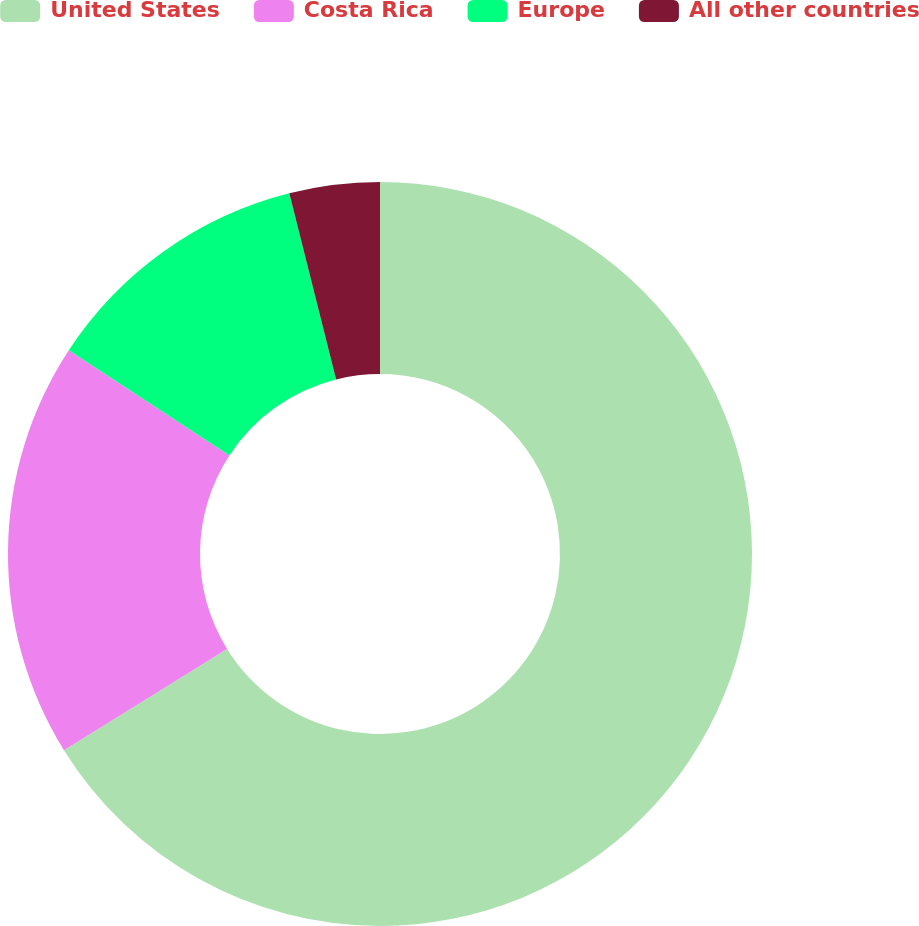<chart> <loc_0><loc_0><loc_500><loc_500><pie_chart><fcel>United States<fcel>Costa Rica<fcel>Europe<fcel>All other countries<nl><fcel>66.15%<fcel>18.07%<fcel>11.85%<fcel>3.92%<nl></chart> 